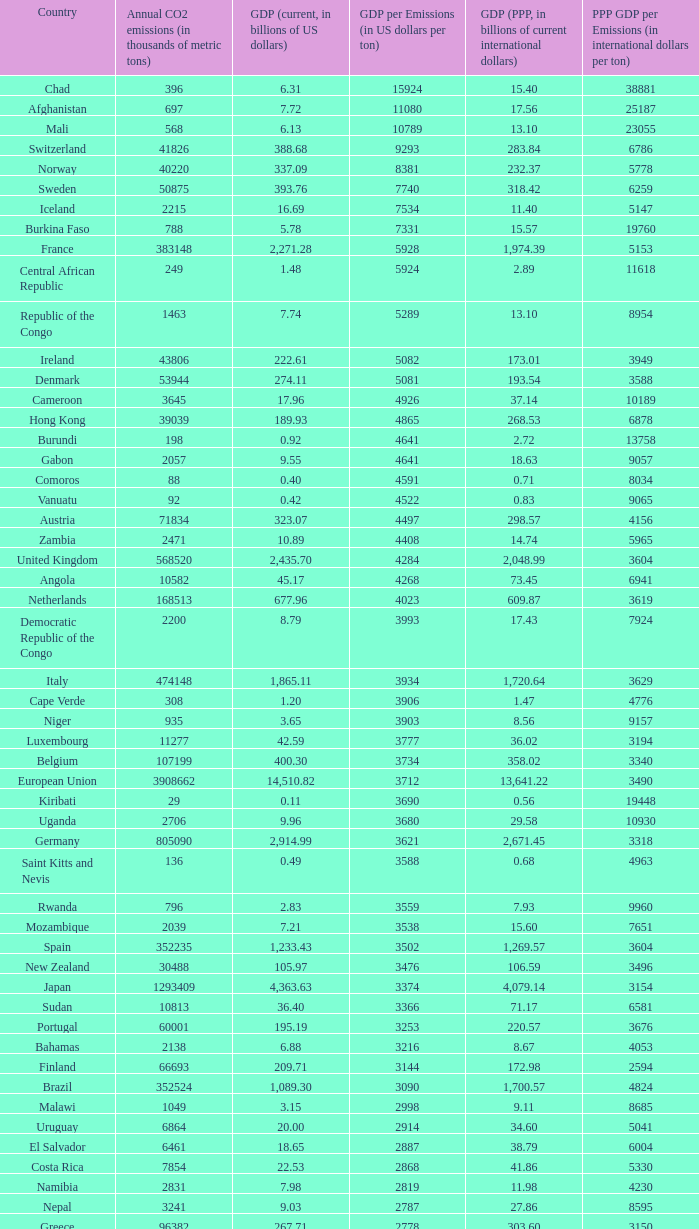93, what is the top ppp gdp per emissions (in international dollars per ton)? 9960.0. 